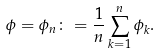Convert formula to latex. <formula><loc_0><loc_0><loc_500><loc_500>\phi = \phi _ { n } \colon = \frac { 1 } { n } \sum _ { k = 1 } ^ { n } \phi _ { k } .</formula> 